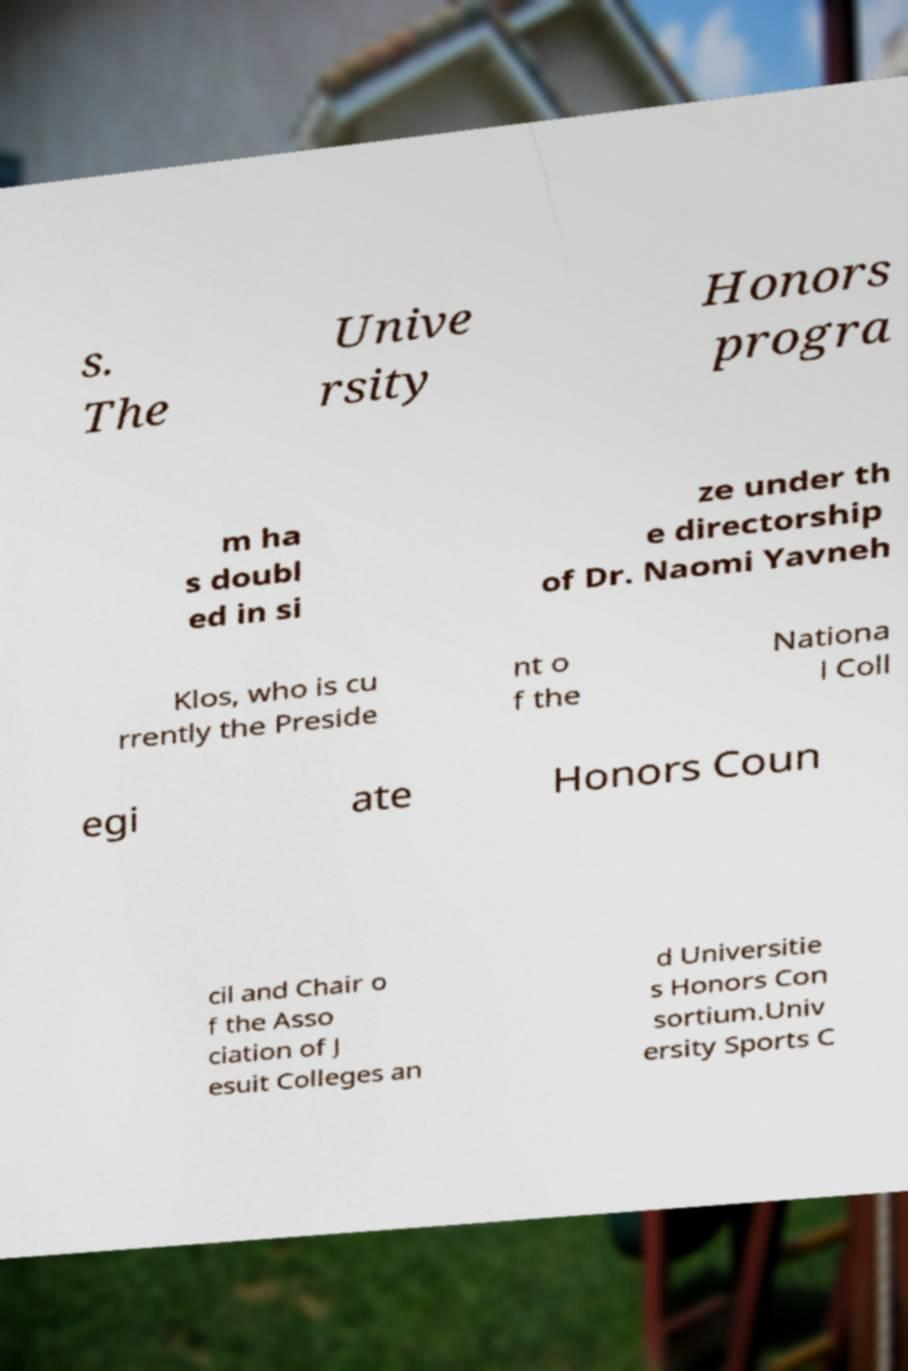Could you assist in decoding the text presented in this image and type it out clearly? s. The Unive rsity Honors progra m ha s doubl ed in si ze under th e directorship of Dr. Naomi Yavneh Klos, who is cu rrently the Preside nt o f the Nationa l Coll egi ate Honors Coun cil and Chair o f the Asso ciation of J esuit Colleges an d Universitie s Honors Con sortium.Univ ersity Sports C 